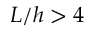<formula> <loc_0><loc_0><loc_500><loc_500>L / h > 4</formula> 